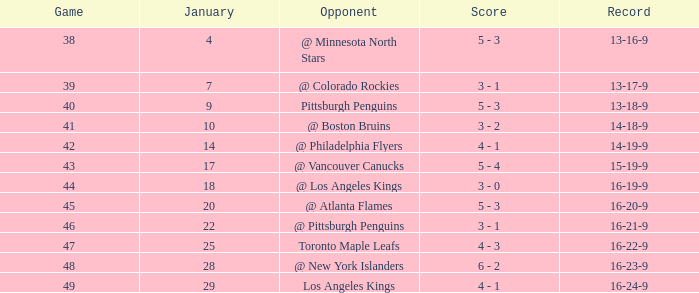What was the record after the game before Jan 7? 13-16-9. 